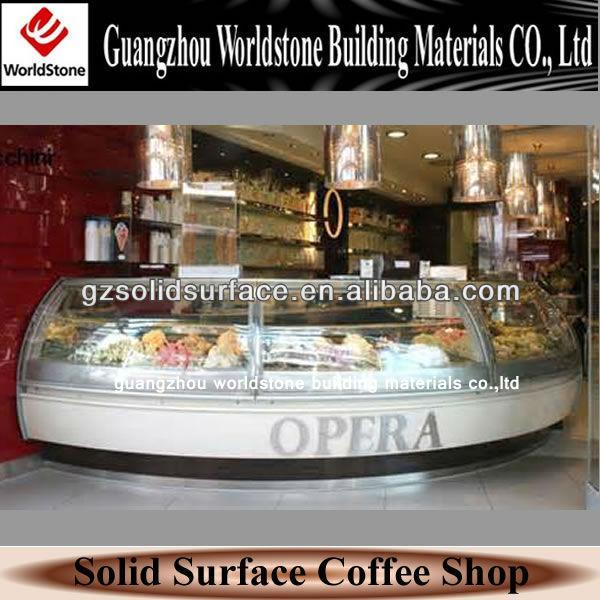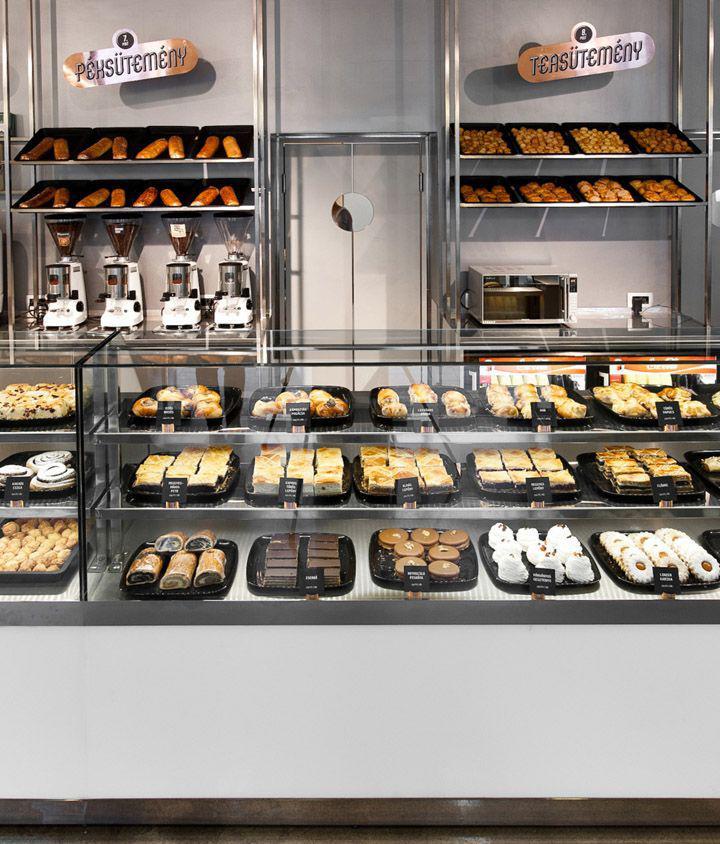The first image is the image on the left, the second image is the image on the right. For the images displayed, is the sentence "One image shows a small seating area for customers." factually correct? Answer yes or no. No. 